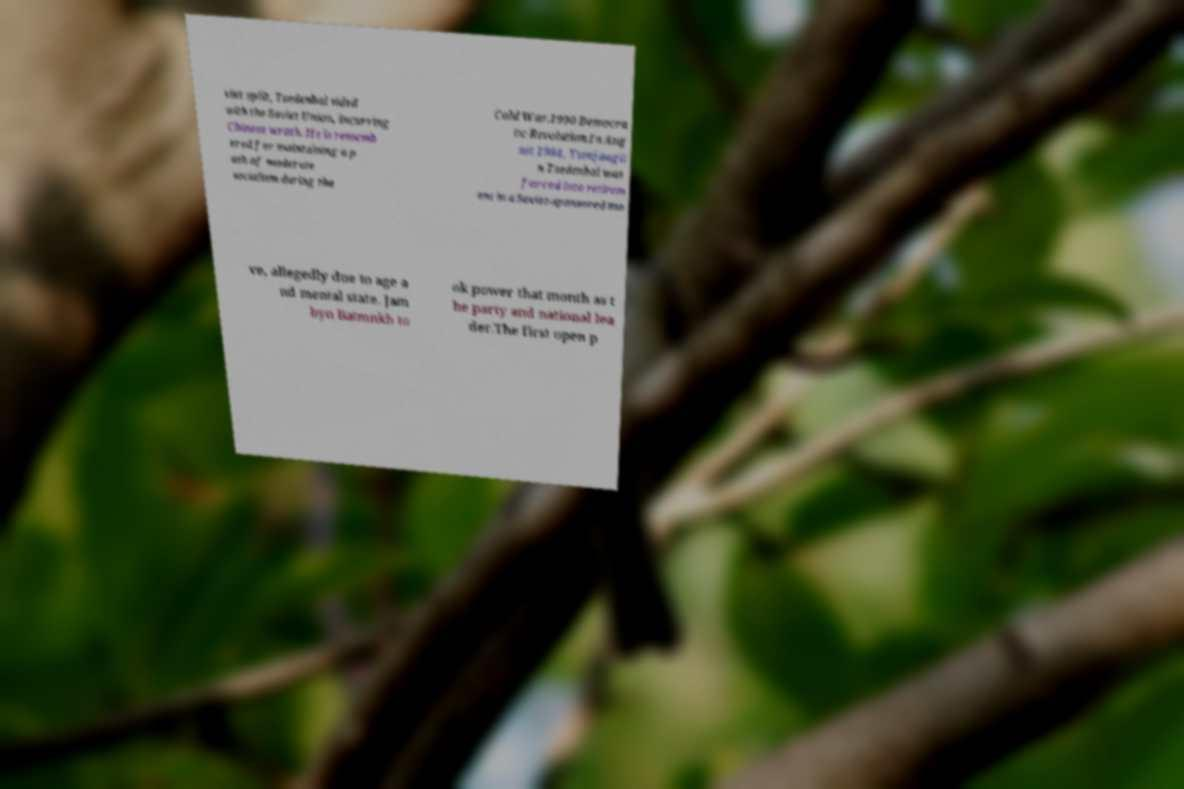There's text embedded in this image that I need extracted. Can you transcribe it verbatim? viet split, Tsedenbal sided with the Soviet Union, incurring Chinese wrath. He is rememb ered for maintaining a p ath of moderate socialism during the Cold War.1990 Democra tic Revolution.In Aug ust 1984, Yumjaagii n Tsedenbal was forced into retirem ent in a Soviet-sponsored mo ve, allegedly due to age a nd mental state. Jam byn Batmnkh to ok power that month as t he party and national lea der.The first open p 